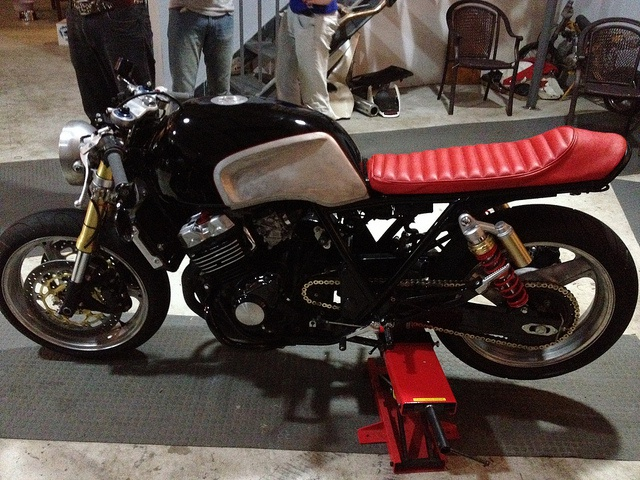Describe the objects in this image and their specific colors. I can see motorcycle in maroon, black, gray, and white tones, people in maroon, black, gray, and darkgray tones, chair in maroon, black, and gray tones, people in maroon, gray, darkgray, and black tones, and people in maroon, black, gray, and darkgray tones in this image. 